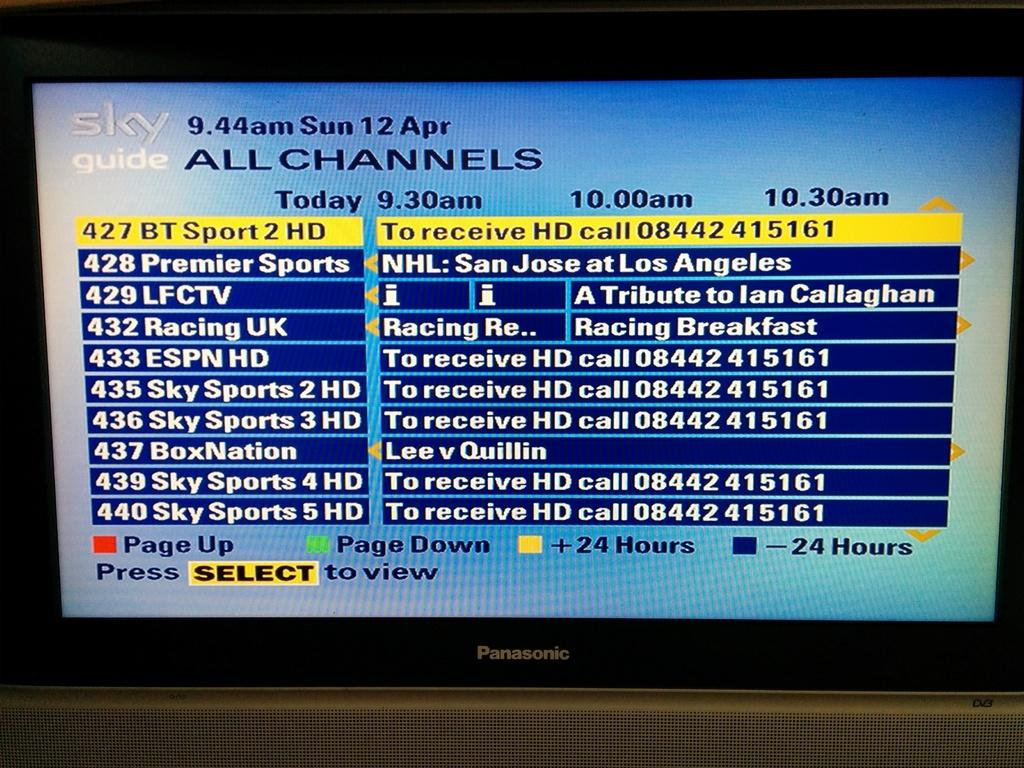<image>
Share a concise interpretation of the image provided. A TV screen shows the sports menu of SkyTv at 9.44am on 12th April 